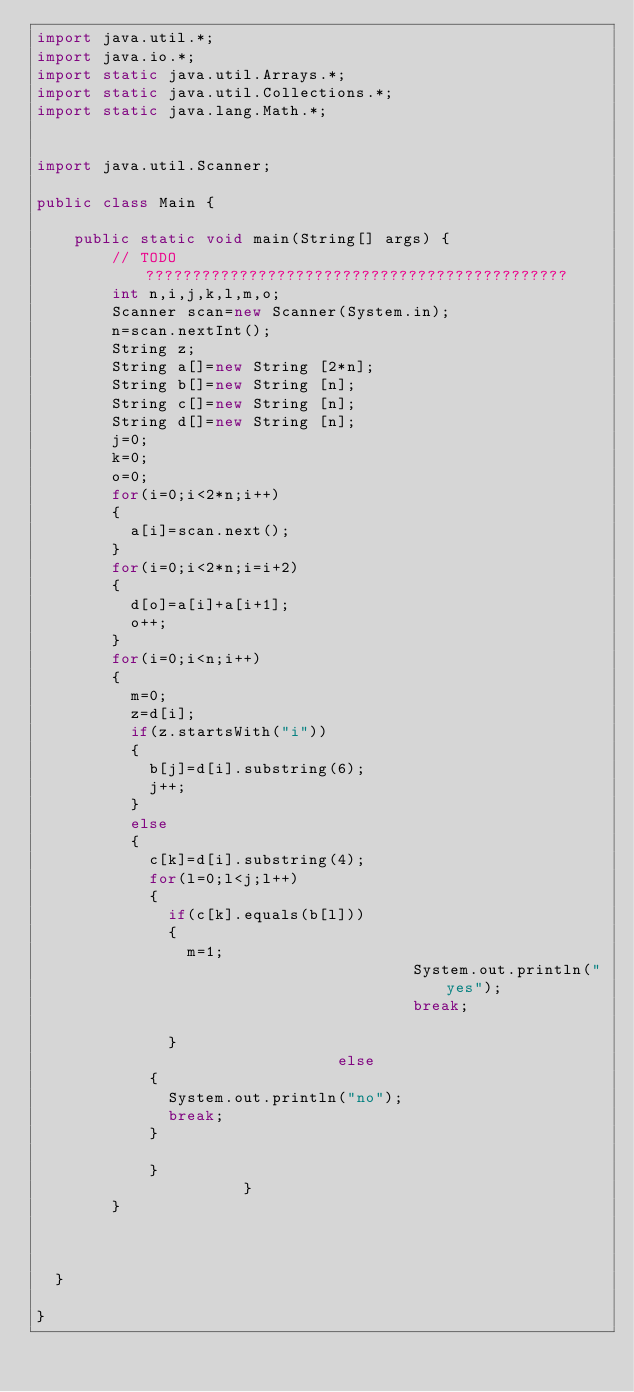Convert code to text. <code><loc_0><loc_0><loc_500><loc_500><_Java_>import java.util.*;
import java.io.*;
import static java.util.Arrays.*;
import static java.util.Collections.*;
import static java.lang.Math.*;
 
 
import java.util.Scanner;
 
public class Main {
 
    public static void main(String[] args) {
        // TODO ?????????????????????????????????????????????
        int n,i,j,k,l,m,o;
        Scanner scan=new Scanner(System.in);
        n=scan.nextInt();
        String z;
        String a[]=new String [2*n];
        String b[]=new String [n];
        String c[]=new String [n];
        String d[]=new String [n];
        j=0;
        k=0;
        o=0;
        for(i=0;i<2*n;i++)
        {
        	a[i]=scan.next();
        }
        for(i=0;i<2*n;i=i+2)
        {
        	d[o]=a[i]+a[i+1];
        	o++;
        }
        for(i=0;i<n;i++)
        {
        	m=0;
        	z=d[i];
        	if(z.startsWith("i"))
        	{
        		b[j]=d[i].substring(6);
        		j++;
        	}
        	else
        	{
        		c[k]=d[i].substring(4);
        		for(l=0;l<j;l++)
        		{
        			if(c[k].equals(b[l]))
        			{
        				m=1;
                                        System.out.println("yes");
                                        break;

        			}
                                else
        		{
        			System.out.println("no");
        			break;
        		}

        		}
        		        	}
        }
       
        
        
	}

}</code> 